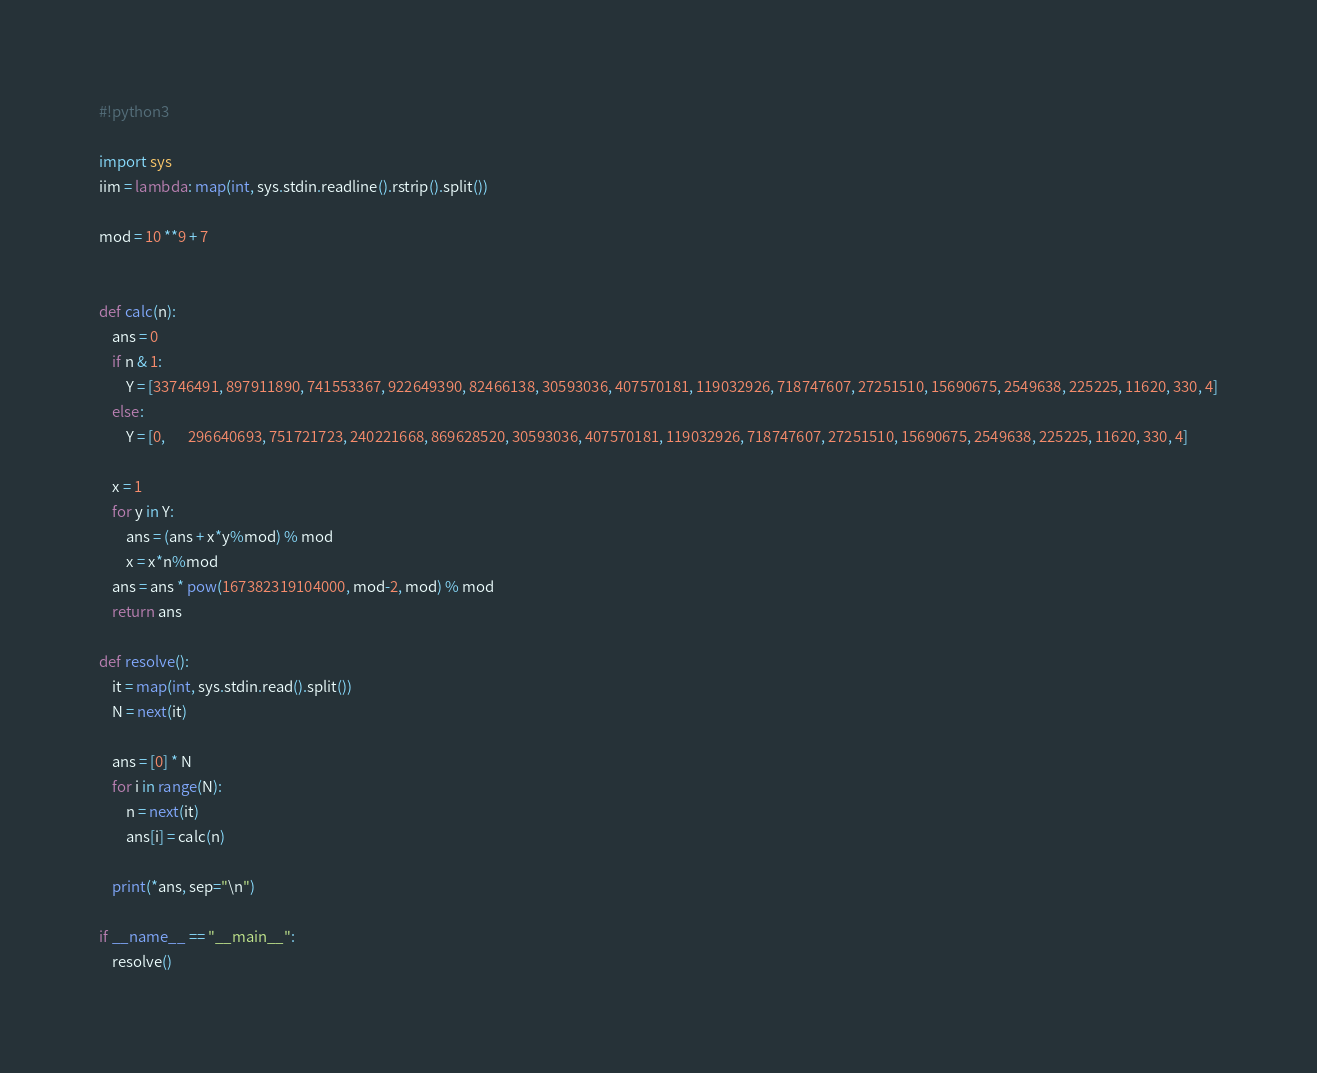Convert code to text. <code><loc_0><loc_0><loc_500><loc_500><_Python_>#!python3

import sys
iim = lambda: map(int, sys.stdin.readline().rstrip().split())

mod = 10 **9 + 7


def calc(n):
    ans = 0
    if n & 1:
        Y = [33746491, 897911890, 741553367, 922649390, 82466138, 30593036, 407570181, 119032926, 718747607, 27251510, 15690675, 2549638, 225225, 11620, 330, 4]
    else:
        Y = [0,       296640693, 751721723, 240221668, 869628520, 30593036, 407570181, 119032926, 718747607, 27251510, 15690675, 2549638, 225225, 11620, 330, 4]

    x = 1
    for y in Y:
        ans = (ans + x*y%mod) % mod
        x = x*n%mod
    ans = ans * pow(167382319104000, mod-2, mod) % mod
    return ans

def resolve():
    it = map(int, sys.stdin.read().split())
    N = next(it)

    ans = [0] * N
    for i in range(N):
        n = next(it)
        ans[i] = calc(n)

    print(*ans, sep="\n")

if __name__ == "__main__":
    resolve()
</code> 